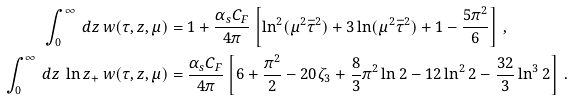<formula> <loc_0><loc_0><loc_500><loc_500>\int _ { 0 } ^ { \infty } \, d z \, w ( \tau , z , \mu ) & = 1 + \frac { \alpha _ { s } C _ { F } } { 4 \pi } \left [ \ln ^ { 2 } ( \mu ^ { 2 } \bar { \tau } ^ { 2 } ) + 3 \ln ( \mu ^ { 2 } \bar { \tau } ^ { 2 } ) + 1 - \frac { 5 \pi ^ { 2 } } { 6 } \right ] \, , \\ \int _ { 0 } ^ { \infty } \, d z \, \ln z _ { + } \, w ( \tau , z , \mu ) & = \frac { \alpha _ { s } C _ { F } } { 4 \pi } \left [ 6 + \frac { \pi ^ { 2 } } { 2 } - 2 0 \zeta _ { 3 } + \frac { 8 } { 3 } \pi ^ { 2 } \ln 2 - 1 2 \ln ^ { 2 } 2 - \frac { 3 2 } { 3 } \ln ^ { 3 } 2 \right ] \, .</formula> 